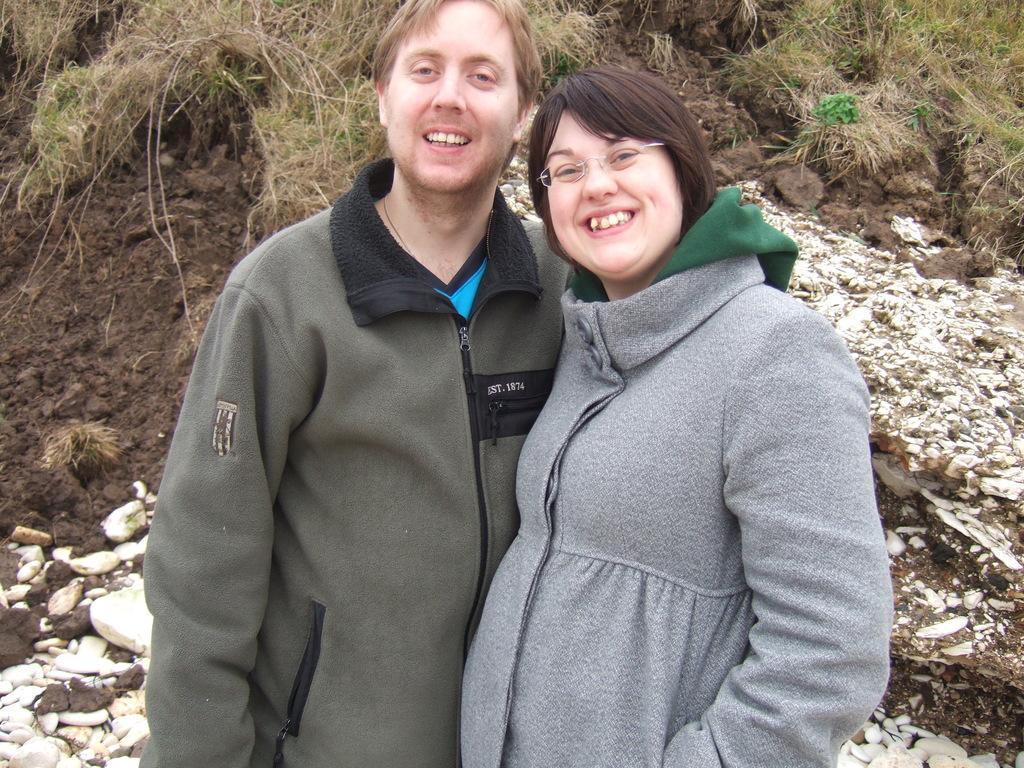Describe this image in one or two sentences. In the image there are two people standing in the foreground and they are laughing, in the background there is grass and soil. 